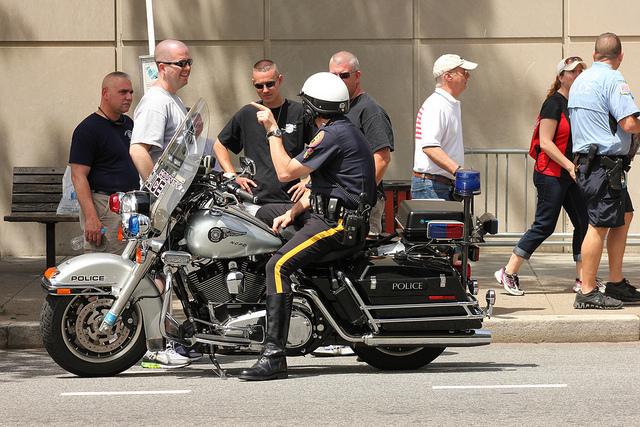What is happening to the man?
Give a very brief answer. Talking. Is the motorcycle moving?
Quick response, please. No. Who is on the bike?
Quick response, please. Police officer. Are some people in trouble?
Keep it brief. Yes. Is the policeman trying to arrest someone?
Keep it brief. No. How many men are in this picture?
Concise answer only. 7. 